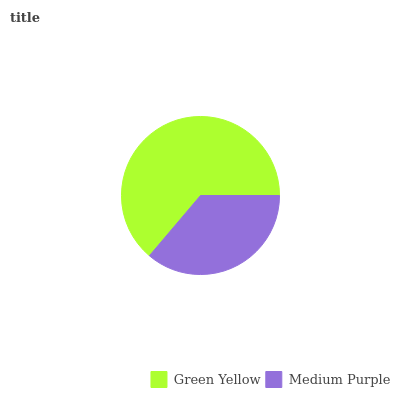Is Medium Purple the minimum?
Answer yes or no. Yes. Is Green Yellow the maximum?
Answer yes or no. Yes. Is Medium Purple the maximum?
Answer yes or no. No. Is Green Yellow greater than Medium Purple?
Answer yes or no. Yes. Is Medium Purple less than Green Yellow?
Answer yes or no. Yes. Is Medium Purple greater than Green Yellow?
Answer yes or no. No. Is Green Yellow less than Medium Purple?
Answer yes or no. No. Is Green Yellow the high median?
Answer yes or no. Yes. Is Medium Purple the low median?
Answer yes or no. Yes. Is Medium Purple the high median?
Answer yes or no. No. Is Green Yellow the low median?
Answer yes or no. No. 